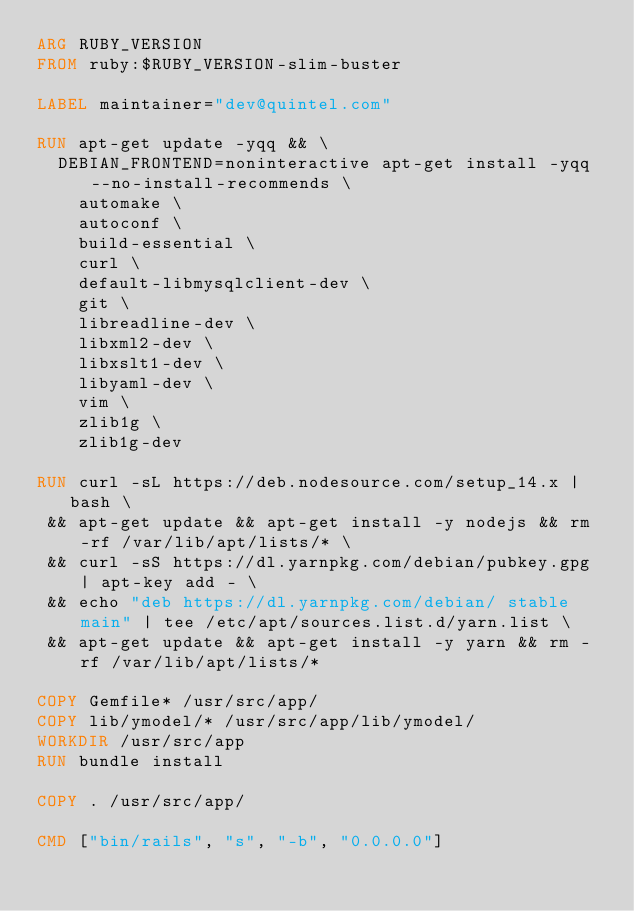<code> <loc_0><loc_0><loc_500><loc_500><_Dockerfile_>ARG RUBY_VERSION
FROM ruby:$RUBY_VERSION-slim-buster

LABEL maintainer="dev@quintel.com"

RUN apt-get update -yqq && \
  DEBIAN_FRONTEND=noninteractive apt-get install -yqq --no-install-recommends \
    automake \
    autoconf \
    build-essential \
    curl \
    default-libmysqlclient-dev \
    git \
    libreadline-dev \
    libxml2-dev \
    libxslt1-dev \
    libyaml-dev \
    vim \
    zlib1g \
    zlib1g-dev

RUN curl -sL https://deb.nodesource.com/setup_14.x | bash \
 && apt-get update && apt-get install -y nodejs && rm -rf /var/lib/apt/lists/* \
 && curl -sS https://dl.yarnpkg.com/debian/pubkey.gpg | apt-key add - \
 && echo "deb https://dl.yarnpkg.com/debian/ stable main" | tee /etc/apt/sources.list.d/yarn.list \
 && apt-get update && apt-get install -y yarn && rm -rf /var/lib/apt/lists/*

COPY Gemfile* /usr/src/app/
COPY lib/ymodel/* /usr/src/app/lib/ymodel/
WORKDIR /usr/src/app
RUN bundle install

COPY . /usr/src/app/

CMD ["bin/rails", "s", "-b", "0.0.0.0"]
</code> 